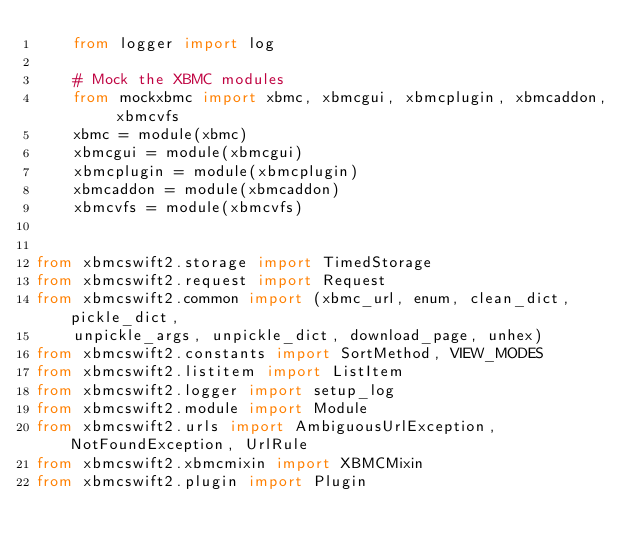Convert code to text. <code><loc_0><loc_0><loc_500><loc_500><_Python_>    from logger import log

    # Mock the XBMC modules
    from mockxbmc import xbmc, xbmcgui, xbmcplugin, xbmcaddon, xbmcvfs
    xbmc = module(xbmc)
    xbmcgui = module(xbmcgui)
    xbmcplugin = module(xbmcplugin)
    xbmcaddon = module(xbmcaddon)
    xbmcvfs = module(xbmcvfs)


from xbmcswift2.storage import TimedStorage
from xbmcswift2.request import Request
from xbmcswift2.common import (xbmc_url, enum, clean_dict, pickle_dict,
    unpickle_args, unpickle_dict, download_page, unhex)
from xbmcswift2.constants import SortMethod, VIEW_MODES
from xbmcswift2.listitem import ListItem
from xbmcswift2.logger import setup_log
from xbmcswift2.module import Module
from xbmcswift2.urls import AmbiguousUrlException, NotFoundException, UrlRule
from xbmcswift2.xbmcmixin import XBMCMixin
from xbmcswift2.plugin import Plugin
</code> 